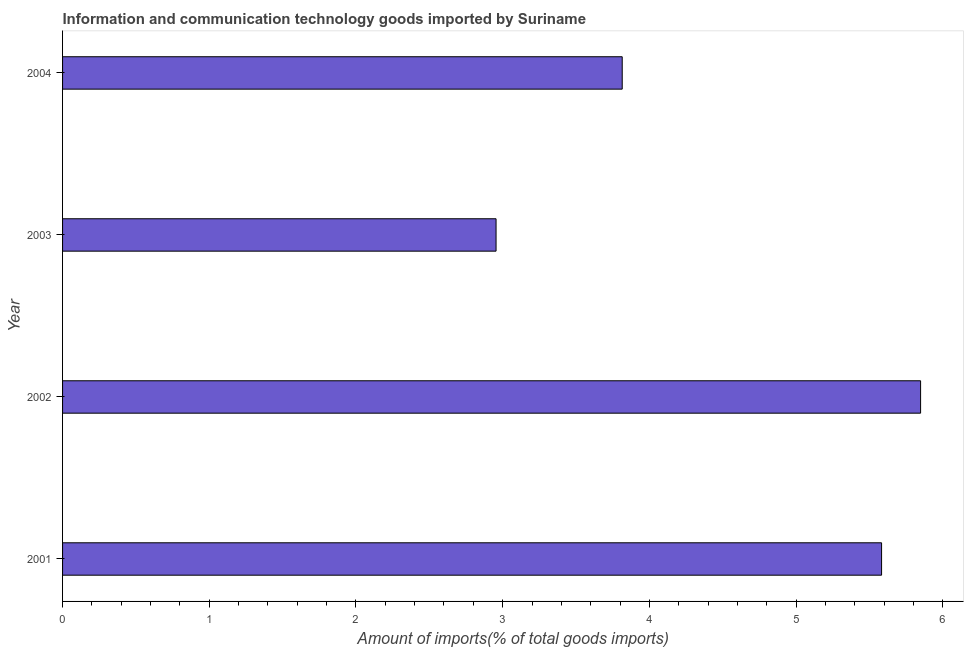Does the graph contain any zero values?
Provide a short and direct response. No. Does the graph contain grids?
Give a very brief answer. No. What is the title of the graph?
Offer a very short reply. Information and communication technology goods imported by Suriname. What is the label or title of the X-axis?
Provide a short and direct response. Amount of imports(% of total goods imports). What is the label or title of the Y-axis?
Make the answer very short. Year. What is the amount of ict goods imports in 2003?
Your answer should be very brief. 2.95. Across all years, what is the maximum amount of ict goods imports?
Make the answer very short. 5.85. Across all years, what is the minimum amount of ict goods imports?
Provide a succinct answer. 2.95. In which year was the amount of ict goods imports maximum?
Your answer should be compact. 2002. In which year was the amount of ict goods imports minimum?
Your response must be concise. 2003. What is the sum of the amount of ict goods imports?
Provide a succinct answer. 18.2. What is the difference between the amount of ict goods imports in 2003 and 2004?
Give a very brief answer. -0.86. What is the average amount of ict goods imports per year?
Offer a very short reply. 4.55. What is the median amount of ict goods imports?
Keep it short and to the point. 4.7. In how many years, is the amount of ict goods imports greater than 1.8 %?
Provide a succinct answer. 4. Do a majority of the years between 2001 and 2004 (inclusive) have amount of ict goods imports greater than 1.6 %?
Ensure brevity in your answer.  Yes. What is the ratio of the amount of ict goods imports in 2002 to that in 2003?
Ensure brevity in your answer.  1.98. What is the difference between the highest and the second highest amount of ict goods imports?
Make the answer very short. 0.27. Is the sum of the amount of ict goods imports in 2002 and 2004 greater than the maximum amount of ict goods imports across all years?
Your response must be concise. Yes. What is the difference between the highest and the lowest amount of ict goods imports?
Your answer should be compact. 2.89. How many years are there in the graph?
Provide a succinct answer. 4. What is the difference between two consecutive major ticks on the X-axis?
Keep it short and to the point. 1. What is the Amount of imports(% of total goods imports) of 2001?
Give a very brief answer. 5.58. What is the Amount of imports(% of total goods imports) of 2002?
Provide a short and direct response. 5.85. What is the Amount of imports(% of total goods imports) in 2003?
Your response must be concise. 2.95. What is the Amount of imports(% of total goods imports) in 2004?
Provide a short and direct response. 3.81. What is the difference between the Amount of imports(% of total goods imports) in 2001 and 2002?
Your answer should be very brief. -0.27. What is the difference between the Amount of imports(% of total goods imports) in 2001 and 2003?
Offer a very short reply. 2.63. What is the difference between the Amount of imports(% of total goods imports) in 2001 and 2004?
Keep it short and to the point. 1.77. What is the difference between the Amount of imports(% of total goods imports) in 2002 and 2003?
Make the answer very short. 2.89. What is the difference between the Amount of imports(% of total goods imports) in 2002 and 2004?
Offer a terse response. 2.03. What is the difference between the Amount of imports(% of total goods imports) in 2003 and 2004?
Your response must be concise. -0.86. What is the ratio of the Amount of imports(% of total goods imports) in 2001 to that in 2002?
Your response must be concise. 0.95. What is the ratio of the Amount of imports(% of total goods imports) in 2001 to that in 2003?
Ensure brevity in your answer.  1.89. What is the ratio of the Amount of imports(% of total goods imports) in 2001 to that in 2004?
Keep it short and to the point. 1.46. What is the ratio of the Amount of imports(% of total goods imports) in 2002 to that in 2003?
Your answer should be compact. 1.98. What is the ratio of the Amount of imports(% of total goods imports) in 2002 to that in 2004?
Ensure brevity in your answer.  1.53. What is the ratio of the Amount of imports(% of total goods imports) in 2003 to that in 2004?
Provide a short and direct response. 0.78. 